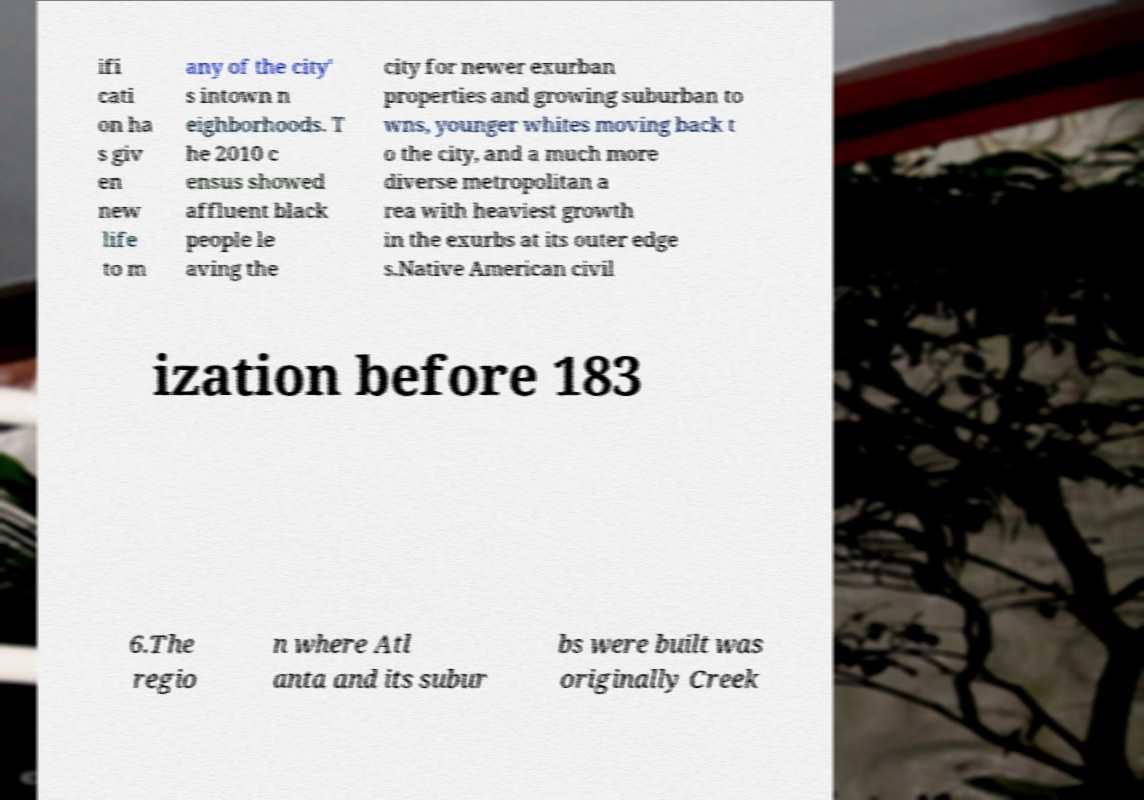For documentation purposes, I need the text within this image transcribed. Could you provide that? ifi cati on ha s giv en new life to m any of the city' s intown n eighborhoods. T he 2010 c ensus showed affluent black people le aving the city for newer exurban properties and growing suburban to wns, younger whites moving back t o the city, and a much more diverse metropolitan a rea with heaviest growth in the exurbs at its outer edge s.Native American civil ization before 183 6.The regio n where Atl anta and its subur bs were built was originally Creek 